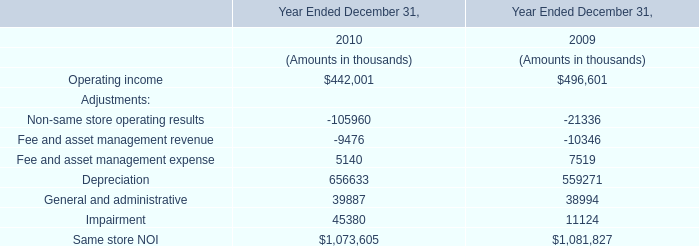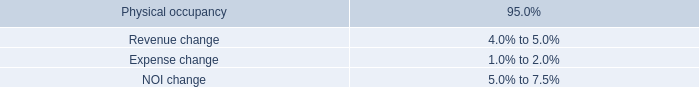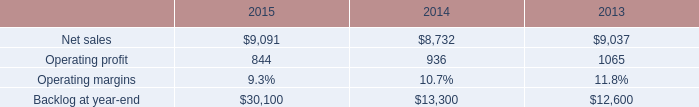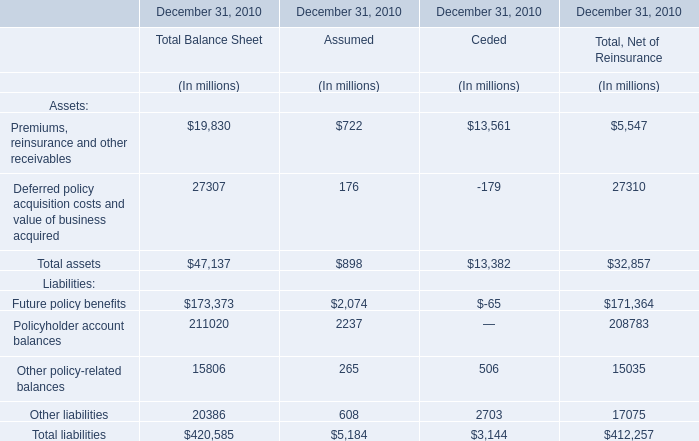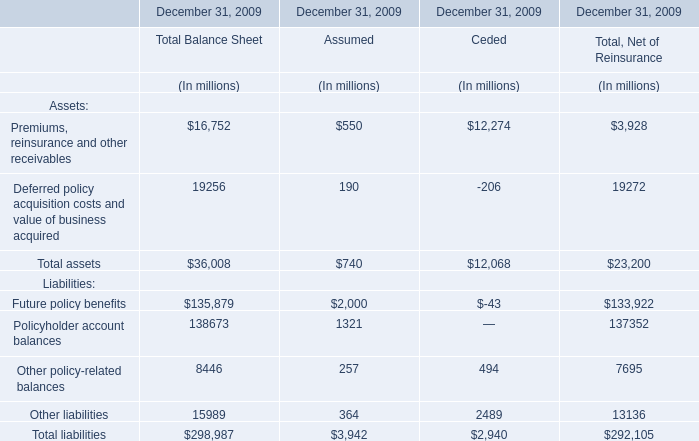what was the percent of the total decline in mst 2019s operating profit in 2015 associated with performance matters 
Computations: (75 / 92)
Answer: 0.81522. 